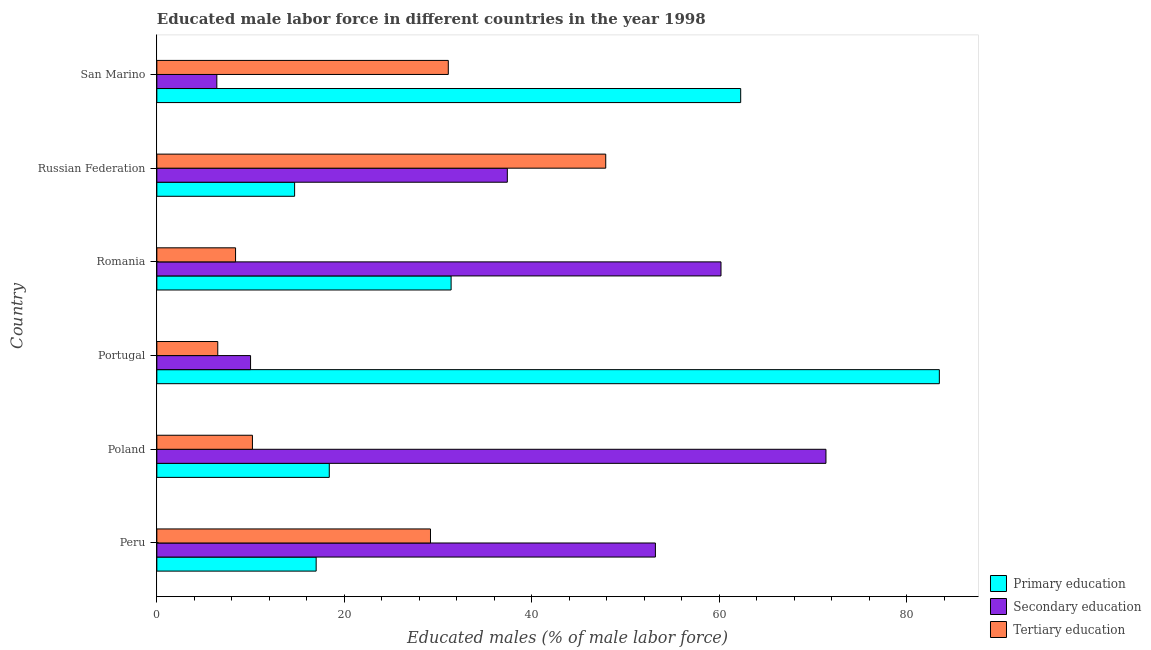How many different coloured bars are there?
Keep it short and to the point. 3. Are the number of bars per tick equal to the number of legend labels?
Ensure brevity in your answer.  Yes. Are the number of bars on each tick of the Y-axis equal?
Ensure brevity in your answer.  Yes. In how many cases, is the number of bars for a given country not equal to the number of legend labels?
Your answer should be very brief. 0. What is the percentage of male labor force who received tertiary education in Russian Federation?
Ensure brevity in your answer.  47.9. Across all countries, what is the maximum percentage of male labor force who received primary education?
Make the answer very short. 83.5. In which country was the percentage of male labor force who received secondary education maximum?
Offer a very short reply. Poland. In which country was the percentage of male labor force who received secondary education minimum?
Offer a very short reply. San Marino. What is the total percentage of male labor force who received primary education in the graph?
Your answer should be compact. 227.3. What is the difference between the percentage of male labor force who received secondary education in Romania and that in San Marino?
Your answer should be very brief. 53.8. What is the difference between the percentage of male labor force who received secondary education in San Marino and the percentage of male labor force who received primary education in Portugal?
Offer a terse response. -77.1. What is the average percentage of male labor force who received secondary education per country?
Your answer should be very brief. 39.77. What is the difference between the percentage of male labor force who received primary education and percentage of male labor force who received tertiary education in Peru?
Your answer should be compact. -12.2. In how many countries, is the percentage of male labor force who received secondary education greater than 76 %?
Ensure brevity in your answer.  0. What is the ratio of the percentage of male labor force who received secondary education in Peru to that in Russian Federation?
Offer a very short reply. 1.42. What is the difference between the highest and the lowest percentage of male labor force who received primary education?
Give a very brief answer. 68.8. In how many countries, is the percentage of male labor force who received tertiary education greater than the average percentage of male labor force who received tertiary education taken over all countries?
Your response must be concise. 3. What does the 3rd bar from the top in Russian Federation represents?
Your response must be concise. Primary education. What does the 3rd bar from the bottom in Peru represents?
Provide a succinct answer. Tertiary education. Is it the case that in every country, the sum of the percentage of male labor force who received primary education and percentage of male labor force who received secondary education is greater than the percentage of male labor force who received tertiary education?
Offer a very short reply. Yes. Are the values on the major ticks of X-axis written in scientific E-notation?
Offer a terse response. No. Does the graph contain any zero values?
Your answer should be compact. No. How many legend labels are there?
Ensure brevity in your answer.  3. What is the title of the graph?
Offer a very short reply. Educated male labor force in different countries in the year 1998. What is the label or title of the X-axis?
Provide a short and direct response. Educated males (% of male labor force). What is the Educated males (% of male labor force) in Secondary education in Peru?
Your response must be concise. 53.2. What is the Educated males (% of male labor force) in Tertiary education in Peru?
Offer a terse response. 29.2. What is the Educated males (% of male labor force) of Primary education in Poland?
Ensure brevity in your answer.  18.4. What is the Educated males (% of male labor force) in Secondary education in Poland?
Provide a short and direct response. 71.4. What is the Educated males (% of male labor force) of Tertiary education in Poland?
Offer a terse response. 10.2. What is the Educated males (% of male labor force) in Primary education in Portugal?
Keep it short and to the point. 83.5. What is the Educated males (% of male labor force) of Secondary education in Portugal?
Offer a very short reply. 10. What is the Educated males (% of male labor force) of Tertiary education in Portugal?
Your answer should be very brief. 6.5. What is the Educated males (% of male labor force) in Primary education in Romania?
Ensure brevity in your answer.  31.4. What is the Educated males (% of male labor force) in Secondary education in Romania?
Offer a very short reply. 60.2. What is the Educated males (% of male labor force) in Tertiary education in Romania?
Your answer should be compact. 8.4. What is the Educated males (% of male labor force) of Primary education in Russian Federation?
Your answer should be very brief. 14.7. What is the Educated males (% of male labor force) in Secondary education in Russian Federation?
Your response must be concise. 37.4. What is the Educated males (% of male labor force) of Tertiary education in Russian Federation?
Make the answer very short. 47.9. What is the Educated males (% of male labor force) of Primary education in San Marino?
Your response must be concise. 62.3. What is the Educated males (% of male labor force) of Secondary education in San Marino?
Your answer should be compact. 6.4. What is the Educated males (% of male labor force) of Tertiary education in San Marino?
Offer a very short reply. 31.1. Across all countries, what is the maximum Educated males (% of male labor force) in Primary education?
Provide a short and direct response. 83.5. Across all countries, what is the maximum Educated males (% of male labor force) in Secondary education?
Your response must be concise. 71.4. Across all countries, what is the maximum Educated males (% of male labor force) in Tertiary education?
Provide a succinct answer. 47.9. Across all countries, what is the minimum Educated males (% of male labor force) in Primary education?
Offer a very short reply. 14.7. Across all countries, what is the minimum Educated males (% of male labor force) of Secondary education?
Provide a succinct answer. 6.4. What is the total Educated males (% of male labor force) of Primary education in the graph?
Make the answer very short. 227.3. What is the total Educated males (% of male labor force) in Secondary education in the graph?
Your answer should be compact. 238.6. What is the total Educated males (% of male labor force) of Tertiary education in the graph?
Your response must be concise. 133.3. What is the difference between the Educated males (% of male labor force) in Secondary education in Peru and that in Poland?
Your answer should be very brief. -18.2. What is the difference between the Educated males (% of male labor force) of Tertiary education in Peru and that in Poland?
Offer a very short reply. 19. What is the difference between the Educated males (% of male labor force) in Primary education in Peru and that in Portugal?
Provide a short and direct response. -66.5. What is the difference between the Educated males (% of male labor force) in Secondary education in Peru and that in Portugal?
Your answer should be very brief. 43.2. What is the difference between the Educated males (% of male labor force) of Tertiary education in Peru and that in Portugal?
Your answer should be very brief. 22.7. What is the difference between the Educated males (% of male labor force) in Primary education in Peru and that in Romania?
Your answer should be compact. -14.4. What is the difference between the Educated males (% of male labor force) in Secondary education in Peru and that in Romania?
Give a very brief answer. -7. What is the difference between the Educated males (% of male labor force) of Tertiary education in Peru and that in Romania?
Offer a very short reply. 20.8. What is the difference between the Educated males (% of male labor force) of Primary education in Peru and that in Russian Federation?
Keep it short and to the point. 2.3. What is the difference between the Educated males (% of male labor force) in Tertiary education in Peru and that in Russian Federation?
Offer a very short reply. -18.7. What is the difference between the Educated males (% of male labor force) in Primary education in Peru and that in San Marino?
Offer a terse response. -45.3. What is the difference between the Educated males (% of male labor force) of Secondary education in Peru and that in San Marino?
Keep it short and to the point. 46.8. What is the difference between the Educated males (% of male labor force) of Primary education in Poland and that in Portugal?
Provide a succinct answer. -65.1. What is the difference between the Educated males (% of male labor force) in Secondary education in Poland and that in Portugal?
Provide a short and direct response. 61.4. What is the difference between the Educated males (% of male labor force) of Tertiary education in Poland and that in Russian Federation?
Ensure brevity in your answer.  -37.7. What is the difference between the Educated males (% of male labor force) of Primary education in Poland and that in San Marino?
Keep it short and to the point. -43.9. What is the difference between the Educated males (% of male labor force) of Tertiary education in Poland and that in San Marino?
Offer a very short reply. -20.9. What is the difference between the Educated males (% of male labor force) in Primary education in Portugal and that in Romania?
Your response must be concise. 52.1. What is the difference between the Educated males (% of male labor force) in Secondary education in Portugal and that in Romania?
Keep it short and to the point. -50.2. What is the difference between the Educated males (% of male labor force) of Primary education in Portugal and that in Russian Federation?
Give a very brief answer. 68.8. What is the difference between the Educated males (% of male labor force) in Secondary education in Portugal and that in Russian Federation?
Your answer should be compact. -27.4. What is the difference between the Educated males (% of male labor force) in Tertiary education in Portugal and that in Russian Federation?
Make the answer very short. -41.4. What is the difference between the Educated males (% of male labor force) of Primary education in Portugal and that in San Marino?
Give a very brief answer. 21.2. What is the difference between the Educated males (% of male labor force) of Secondary education in Portugal and that in San Marino?
Your answer should be very brief. 3.6. What is the difference between the Educated males (% of male labor force) in Tertiary education in Portugal and that in San Marino?
Ensure brevity in your answer.  -24.6. What is the difference between the Educated males (% of male labor force) of Primary education in Romania and that in Russian Federation?
Make the answer very short. 16.7. What is the difference between the Educated males (% of male labor force) of Secondary education in Romania and that in Russian Federation?
Make the answer very short. 22.8. What is the difference between the Educated males (% of male labor force) of Tertiary education in Romania and that in Russian Federation?
Offer a terse response. -39.5. What is the difference between the Educated males (% of male labor force) of Primary education in Romania and that in San Marino?
Your answer should be compact. -30.9. What is the difference between the Educated males (% of male labor force) of Secondary education in Romania and that in San Marino?
Provide a short and direct response. 53.8. What is the difference between the Educated males (% of male labor force) of Tertiary education in Romania and that in San Marino?
Give a very brief answer. -22.7. What is the difference between the Educated males (% of male labor force) in Primary education in Russian Federation and that in San Marino?
Your answer should be very brief. -47.6. What is the difference between the Educated males (% of male labor force) of Secondary education in Russian Federation and that in San Marino?
Offer a very short reply. 31. What is the difference between the Educated males (% of male labor force) in Tertiary education in Russian Federation and that in San Marino?
Provide a succinct answer. 16.8. What is the difference between the Educated males (% of male labor force) in Primary education in Peru and the Educated males (% of male labor force) in Secondary education in Poland?
Your answer should be compact. -54.4. What is the difference between the Educated males (% of male labor force) of Secondary education in Peru and the Educated males (% of male labor force) of Tertiary education in Poland?
Ensure brevity in your answer.  43. What is the difference between the Educated males (% of male labor force) of Primary education in Peru and the Educated males (% of male labor force) of Secondary education in Portugal?
Offer a terse response. 7. What is the difference between the Educated males (% of male labor force) of Primary education in Peru and the Educated males (% of male labor force) of Tertiary education in Portugal?
Give a very brief answer. 10.5. What is the difference between the Educated males (% of male labor force) in Secondary education in Peru and the Educated males (% of male labor force) in Tertiary education in Portugal?
Keep it short and to the point. 46.7. What is the difference between the Educated males (% of male labor force) of Primary education in Peru and the Educated males (% of male labor force) of Secondary education in Romania?
Keep it short and to the point. -43.2. What is the difference between the Educated males (% of male labor force) in Primary education in Peru and the Educated males (% of male labor force) in Tertiary education in Romania?
Ensure brevity in your answer.  8.6. What is the difference between the Educated males (% of male labor force) in Secondary education in Peru and the Educated males (% of male labor force) in Tertiary education in Romania?
Provide a succinct answer. 44.8. What is the difference between the Educated males (% of male labor force) in Primary education in Peru and the Educated males (% of male labor force) in Secondary education in Russian Federation?
Your response must be concise. -20.4. What is the difference between the Educated males (% of male labor force) of Primary education in Peru and the Educated males (% of male labor force) of Tertiary education in Russian Federation?
Offer a very short reply. -30.9. What is the difference between the Educated males (% of male labor force) in Primary education in Peru and the Educated males (% of male labor force) in Tertiary education in San Marino?
Your response must be concise. -14.1. What is the difference between the Educated males (% of male labor force) in Secondary education in Peru and the Educated males (% of male labor force) in Tertiary education in San Marino?
Your response must be concise. 22.1. What is the difference between the Educated males (% of male labor force) in Secondary education in Poland and the Educated males (% of male labor force) in Tertiary education in Portugal?
Offer a very short reply. 64.9. What is the difference between the Educated males (% of male labor force) in Primary education in Poland and the Educated males (% of male labor force) in Secondary education in Romania?
Your response must be concise. -41.8. What is the difference between the Educated males (% of male labor force) in Primary education in Poland and the Educated males (% of male labor force) in Tertiary education in Russian Federation?
Your answer should be compact. -29.5. What is the difference between the Educated males (% of male labor force) in Primary education in Poland and the Educated males (% of male labor force) in Secondary education in San Marino?
Give a very brief answer. 12. What is the difference between the Educated males (% of male labor force) in Primary education in Poland and the Educated males (% of male labor force) in Tertiary education in San Marino?
Your answer should be very brief. -12.7. What is the difference between the Educated males (% of male labor force) of Secondary education in Poland and the Educated males (% of male labor force) of Tertiary education in San Marino?
Provide a short and direct response. 40.3. What is the difference between the Educated males (% of male labor force) in Primary education in Portugal and the Educated males (% of male labor force) in Secondary education in Romania?
Ensure brevity in your answer.  23.3. What is the difference between the Educated males (% of male labor force) of Primary education in Portugal and the Educated males (% of male labor force) of Tertiary education in Romania?
Your answer should be compact. 75.1. What is the difference between the Educated males (% of male labor force) of Secondary education in Portugal and the Educated males (% of male labor force) of Tertiary education in Romania?
Offer a very short reply. 1.6. What is the difference between the Educated males (% of male labor force) of Primary education in Portugal and the Educated males (% of male labor force) of Secondary education in Russian Federation?
Offer a terse response. 46.1. What is the difference between the Educated males (% of male labor force) of Primary education in Portugal and the Educated males (% of male labor force) of Tertiary education in Russian Federation?
Your answer should be compact. 35.6. What is the difference between the Educated males (% of male labor force) in Secondary education in Portugal and the Educated males (% of male labor force) in Tertiary education in Russian Federation?
Offer a terse response. -37.9. What is the difference between the Educated males (% of male labor force) of Primary education in Portugal and the Educated males (% of male labor force) of Secondary education in San Marino?
Offer a terse response. 77.1. What is the difference between the Educated males (% of male labor force) of Primary education in Portugal and the Educated males (% of male labor force) of Tertiary education in San Marino?
Your response must be concise. 52.4. What is the difference between the Educated males (% of male labor force) of Secondary education in Portugal and the Educated males (% of male labor force) of Tertiary education in San Marino?
Offer a terse response. -21.1. What is the difference between the Educated males (% of male labor force) of Primary education in Romania and the Educated males (% of male labor force) of Tertiary education in Russian Federation?
Ensure brevity in your answer.  -16.5. What is the difference between the Educated males (% of male labor force) in Primary education in Romania and the Educated males (% of male labor force) in Tertiary education in San Marino?
Your answer should be very brief. 0.3. What is the difference between the Educated males (% of male labor force) in Secondary education in Romania and the Educated males (% of male labor force) in Tertiary education in San Marino?
Provide a short and direct response. 29.1. What is the difference between the Educated males (% of male labor force) of Primary education in Russian Federation and the Educated males (% of male labor force) of Tertiary education in San Marino?
Your answer should be very brief. -16.4. What is the difference between the Educated males (% of male labor force) in Secondary education in Russian Federation and the Educated males (% of male labor force) in Tertiary education in San Marino?
Make the answer very short. 6.3. What is the average Educated males (% of male labor force) in Primary education per country?
Provide a short and direct response. 37.88. What is the average Educated males (% of male labor force) in Secondary education per country?
Make the answer very short. 39.77. What is the average Educated males (% of male labor force) of Tertiary education per country?
Your answer should be compact. 22.22. What is the difference between the Educated males (% of male labor force) of Primary education and Educated males (% of male labor force) of Secondary education in Peru?
Your response must be concise. -36.2. What is the difference between the Educated males (% of male labor force) of Secondary education and Educated males (% of male labor force) of Tertiary education in Peru?
Offer a terse response. 24. What is the difference between the Educated males (% of male labor force) in Primary education and Educated males (% of male labor force) in Secondary education in Poland?
Give a very brief answer. -53. What is the difference between the Educated males (% of male labor force) in Primary education and Educated males (% of male labor force) in Tertiary education in Poland?
Offer a terse response. 8.2. What is the difference between the Educated males (% of male labor force) in Secondary education and Educated males (% of male labor force) in Tertiary education in Poland?
Your response must be concise. 61.2. What is the difference between the Educated males (% of male labor force) in Primary education and Educated males (% of male labor force) in Secondary education in Portugal?
Your answer should be compact. 73.5. What is the difference between the Educated males (% of male labor force) of Primary education and Educated males (% of male labor force) of Secondary education in Romania?
Keep it short and to the point. -28.8. What is the difference between the Educated males (% of male labor force) in Primary education and Educated males (% of male labor force) in Tertiary education in Romania?
Keep it short and to the point. 23. What is the difference between the Educated males (% of male labor force) of Secondary education and Educated males (% of male labor force) of Tertiary education in Romania?
Make the answer very short. 51.8. What is the difference between the Educated males (% of male labor force) of Primary education and Educated males (% of male labor force) of Secondary education in Russian Federation?
Your answer should be very brief. -22.7. What is the difference between the Educated males (% of male labor force) in Primary education and Educated males (% of male labor force) in Tertiary education in Russian Federation?
Provide a short and direct response. -33.2. What is the difference between the Educated males (% of male labor force) of Primary education and Educated males (% of male labor force) of Secondary education in San Marino?
Offer a very short reply. 55.9. What is the difference between the Educated males (% of male labor force) of Primary education and Educated males (% of male labor force) of Tertiary education in San Marino?
Offer a very short reply. 31.2. What is the difference between the Educated males (% of male labor force) in Secondary education and Educated males (% of male labor force) in Tertiary education in San Marino?
Offer a very short reply. -24.7. What is the ratio of the Educated males (% of male labor force) in Primary education in Peru to that in Poland?
Provide a succinct answer. 0.92. What is the ratio of the Educated males (% of male labor force) in Secondary education in Peru to that in Poland?
Your answer should be very brief. 0.75. What is the ratio of the Educated males (% of male labor force) in Tertiary education in Peru to that in Poland?
Make the answer very short. 2.86. What is the ratio of the Educated males (% of male labor force) of Primary education in Peru to that in Portugal?
Make the answer very short. 0.2. What is the ratio of the Educated males (% of male labor force) of Secondary education in Peru to that in Portugal?
Give a very brief answer. 5.32. What is the ratio of the Educated males (% of male labor force) in Tertiary education in Peru to that in Portugal?
Ensure brevity in your answer.  4.49. What is the ratio of the Educated males (% of male labor force) in Primary education in Peru to that in Romania?
Provide a succinct answer. 0.54. What is the ratio of the Educated males (% of male labor force) in Secondary education in Peru to that in Romania?
Your answer should be very brief. 0.88. What is the ratio of the Educated males (% of male labor force) in Tertiary education in Peru to that in Romania?
Give a very brief answer. 3.48. What is the ratio of the Educated males (% of male labor force) of Primary education in Peru to that in Russian Federation?
Your response must be concise. 1.16. What is the ratio of the Educated males (% of male labor force) in Secondary education in Peru to that in Russian Federation?
Ensure brevity in your answer.  1.42. What is the ratio of the Educated males (% of male labor force) of Tertiary education in Peru to that in Russian Federation?
Offer a very short reply. 0.61. What is the ratio of the Educated males (% of male labor force) of Primary education in Peru to that in San Marino?
Provide a short and direct response. 0.27. What is the ratio of the Educated males (% of male labor force) in Secondary education in Peru to that in San Marino?
Give a very brief answer. 8.31. What is the ratio of the Educated males (% of male labor force) of Tertiary education in Peru to that in San Marino?
Provide a succinct answer. 0.94. What is the ratio of the Educated males (% of male labor force) in Primary education in Poland to that in Portugal?
Ensure brevity in your answer.  0.22. What is the ratio of the Educated males (% of male labor force) in Secondary education in Poland to that in Portugal?
Ensure brevity in your answer.  7.14. What is the ratio of the Educated males (% of male labor force) of Tertiary education in Poland to that in Portugal?
Your answer should be very brief. 1.57. What is the ratio of the Educated males (% of male labor force) of Primary education in Poland to that in Romania?
Your answer should be very brief. 0.59. What is the ratio of the Educated males (% of male labor force) in Secondary education in Poland to that in Romania?
Ensure brevity in your answer.  1.19. What is the ratio of the Educated males (% of male labor force) in Tertiary education in Poland to that in Romania?
Provide a short and direct response. 1.21. What is the ratio of the Educated males (% of male labor force) of Primary education in Poland to that in Russian Federation?
Give a very brief answer. 1.25. What is the ratio of the Educated males (% of male labor force) of Secondary education in Poland to that in Russian Federation?
Your answer should be very brief. 1.91. What is the ratio of the Educated males (% of male labor force) of Tertiary education in Poland to that in Russian Federation?
Ensure brevity in your answer.  0.21. What is the ratio of the Educated males (% of male labor force) in Primary education in Poland to that in San Marino?
Make the answer very short. 0.3. What is the ratio of the Educated males (% of male labor force) in Secondary education in Poland to that in San Marino?
Provide a succinct answer. 11.16. What is the ratio of the Educated males (% of male labor force) of Tertiary education in Poland to that in San Marino?
Give a very brief answer. 0.33. What is the ratio of the Educated males (% of male labor force) in Primary education in Portugal to that in Romania?
Your answer should be compact. 2.66. What is the ratio of the Educated males (% of male labor force) of Secondary education in Portugal to that in Romania?
Provide a succinct answer. 0.17. What is the ratio of the Educated males (% of male labor force) in Tertiary education in Portugal to that in Romania?
Keep it short and to the point. 0.77. What is the ratio of the Educated males (% of male labor force) of Primary education in Portugal to that in Russian Federation?
Ensure brevity in your answer.  5.68. What is the ratio of the Educated males (% of male labor force) in Secondary education in Portugal to that in Russian Federation?
Ensure brevity in your answer.  0.27. What is the ratio of the Educated males (% of male labor force) of Tertiary education in Portugal to that in Russian Federation?
Give a very brief answer. 0.14. What is the ratio of the Educated males (% of male labor force) in Primary education in Portugal to that in San Marino?
Make the answer very short. 1.34. What is the ratio of the Educated males (% of male labor force) of Secondary education in Portugal to that in San Marino?
Keep it short and to the point. 1.56. What is the ratio of the Educated males (% of male labor force) of Tertiary education in Portugal to that in San Marino?
Make the answer very short. 0.21. What is the ratio of the Educated males (% of male labor force) in Primary education in Romania to that in Russian Federation?
Ensure brevity in your answer.  2.14. What is the ratio of the Educated males (% of male labor force) of Secondary education in Romania to that in Russian Federation?
Your answer should be compact. 1.61. What is the ratio of the Educated males (% of male labor force) in Tertiary education in Romania to that in Russian Federation?
Keep it short and to the point. 0.18. What is the ratio of the Educated males (% of male labor force) of Primary education in Romania to that in San Marino?
Offer a very short reply. 0.5. What is the ratio of the Educated males (% of male labor force) of Secondary education in Romania to that in San Marino?
Your response must be concise. 9.41. What is the ratio of the Educated males (% of male labor force) of Tertiary education in Romania to that in San Marino?
Give a very brief answer. 0.27. What is the ratio of the Educated males (% of male labor force) of Primary education in Russian Federation to that in San Marino?
Provide a succinct answer. 0.24. What is the ratio of the Educated males (% of male labor force) in Secondary education in Russian Federation to that in San Marino?
Ensure brevity in your answer.  5.84. What is the ratio of the Educated males (% of male labor force) of Tertiary education in Russian Federation to that in San Marino?
Make the answer very short. 1.54. What is the difference between the highest and the second highest Educated males (% of male labor force) in Primary education?
Ensure brevity in your answer.  21.2. What is the difference between the highest and the second highest Educated males (% of male labor force) of Tertiary education?
Ensure brevity in your answer.  16.8. What is the difference between the highest and the lowest Educated males (% of male labor force) in Primary education?
Offer a very short reply. 68.8. What is the difference between the highest and the lowest Educated males (% of male labor force) in Tertiary education?
Ensure brevity in your answer.  41.4. 